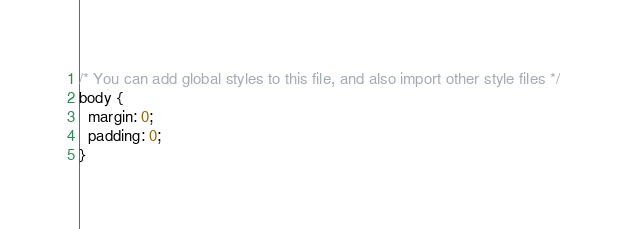Convert code to text. <code><loc_0><loc_0><loc_500><loc_500><_CSS_>/* You can add global styles to this file, and also import other style files */
body {
  margin: 0;
  padding: 0;
}
</code> 